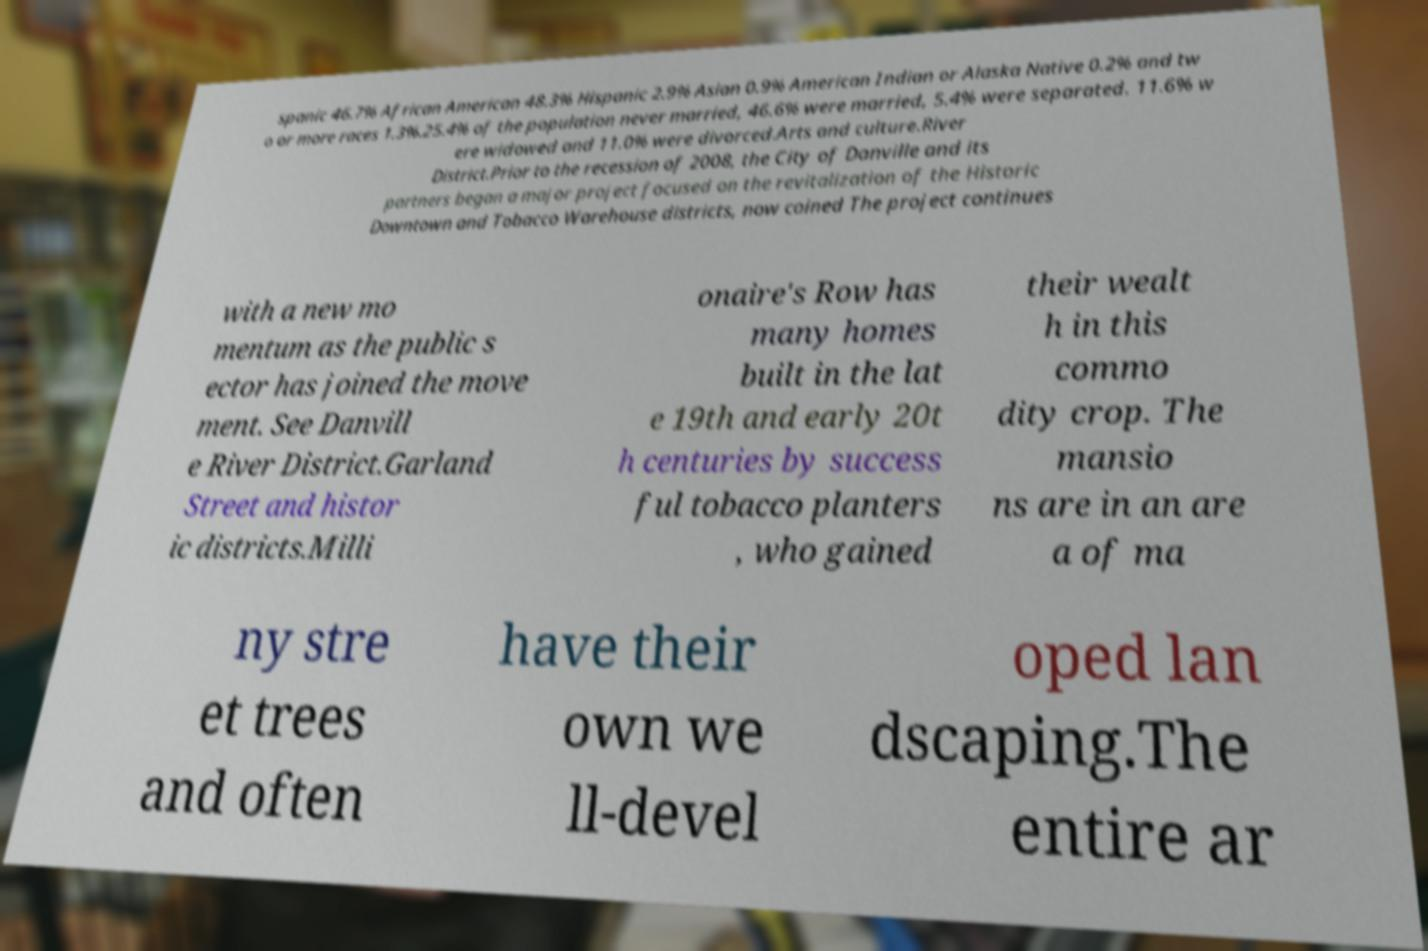What messages or text are displayed in this image? I need them in a readable, typed format. spanic 46.7% African American 48.3% Hispanic 2.9% Asian 0.9% American Indian or Alaska Native 0.2% and tw o or more races 1.3%.25.4% of the population never married, 46.6% were married, 5.4% were separated. 11.6% w ere widowed and 11.0% were divorced.Arts and culture.River District.Prior to the recession of 2008, the City of Danville and its partners began a major project focused on the revitalization of the Historic Downtown and Tobacco Warehouse districts, now coined The project continues with a new mo mentum as the public s ector has joined the move ment. See Danvill e River District.Garland Street and histor ic districts.Milli onaire's Row has many homes built in the lat e 19th and early 20t h centuries by success ful tobacco planters , who gained their wealt h in this commo dity crop. The mansio ns are in an are a of ma ny stre et trees and often have their own we ll-devel oped lan dscaping.The entire ar 